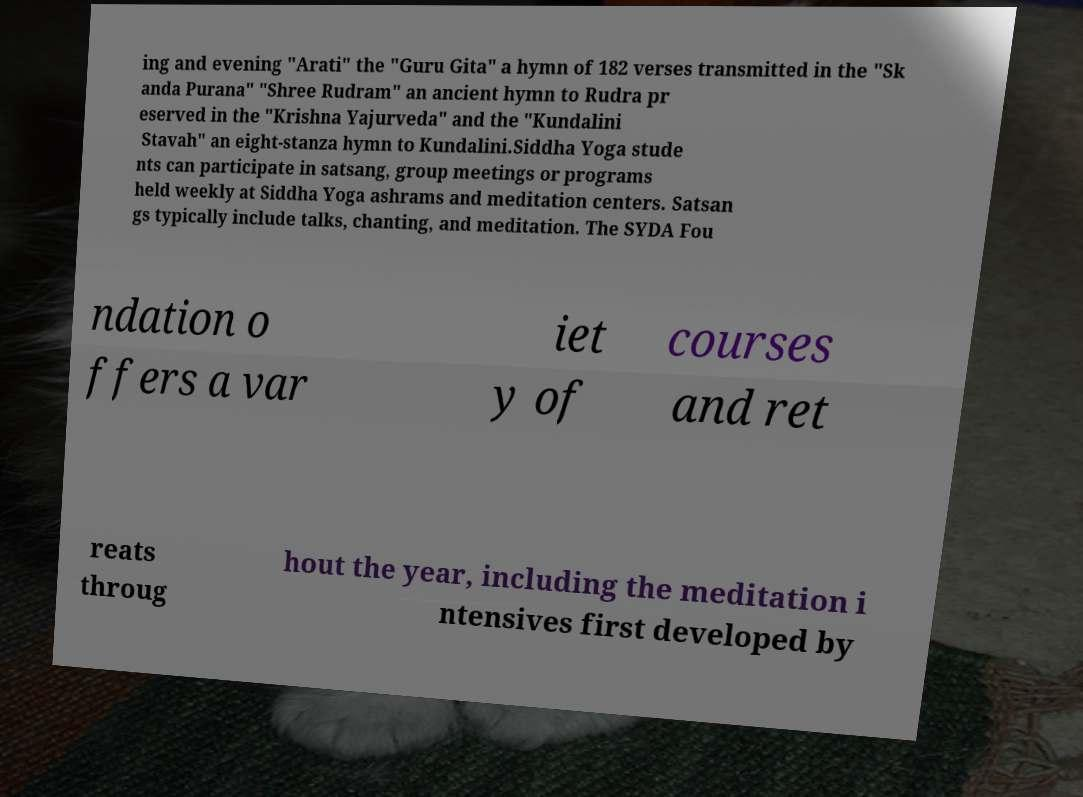Please identify and transcribe the text found in this image. ing and evening "Arati" the "Guru Gita" a hymn of 182 verses transmitted in the "Sk anda Purana" "Shree Rudram" an ancient hymn to Rudra pr eserved in the "Krishna Yajurveda" and the "Kundalini Stavah" an eight-stanza hymn to Kundalini.Siddha Yoga stude nts can participate in satsang, group meetings or programs held weekly at Siddha Yoga ashrams and meditation centers. Satsan gs typically include talks, chanting, and meditation. The SYDA Fou ndation o ffers a var iet y of courses and ret reats throug hout the year, including the meditation i ntensives first developed by 